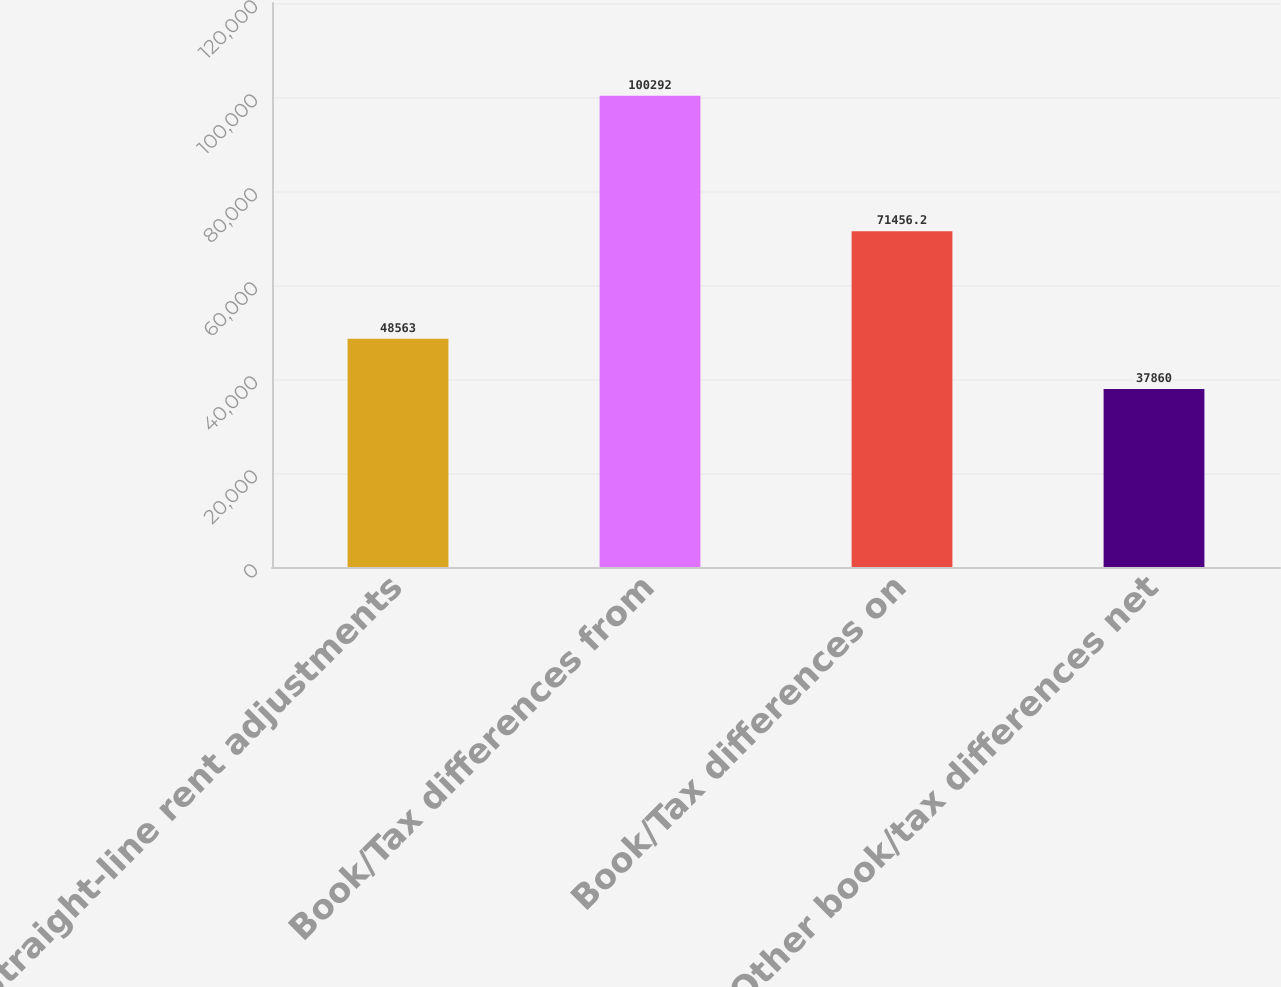<chart> <loc_0><loc_0><loc_500><loc_500><bar_chart><fcel>Straight-line rent adjustments<fcel>Book/Tax differences from<fcel>Book/Tax differences on<fcel>Other book/tax differences net<nl><fcel>48563<fcel>100292<fcel>71456.2<fcel>37860<nl></chart> 